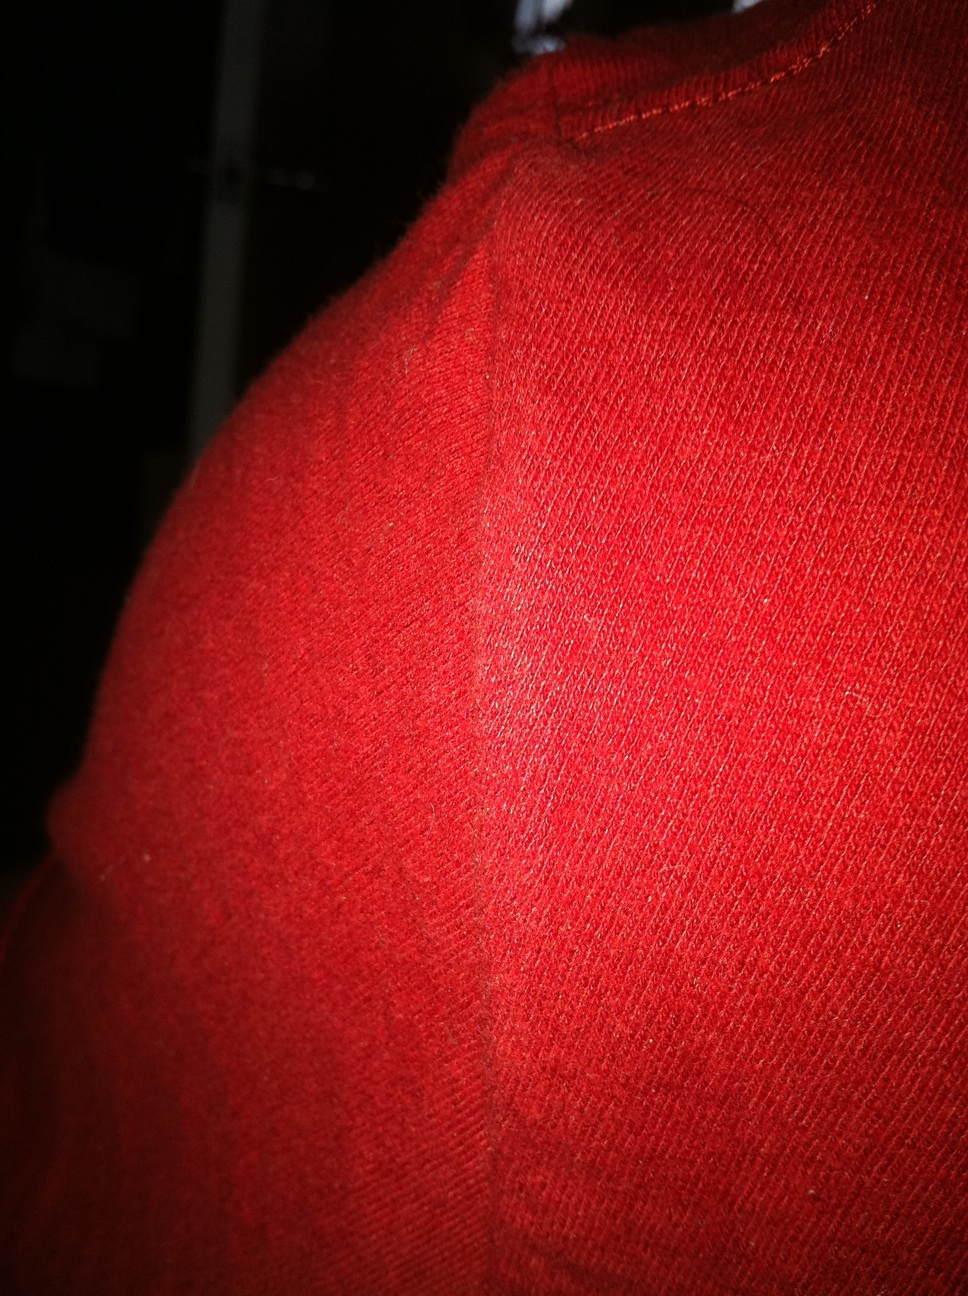What kind of use might this red fabric be suited for? This vibrant red fabric, with its ribbed knitting, makes it ideal for clothing items such as sweaters, beanies, or scarves, providing both warmth and style. 